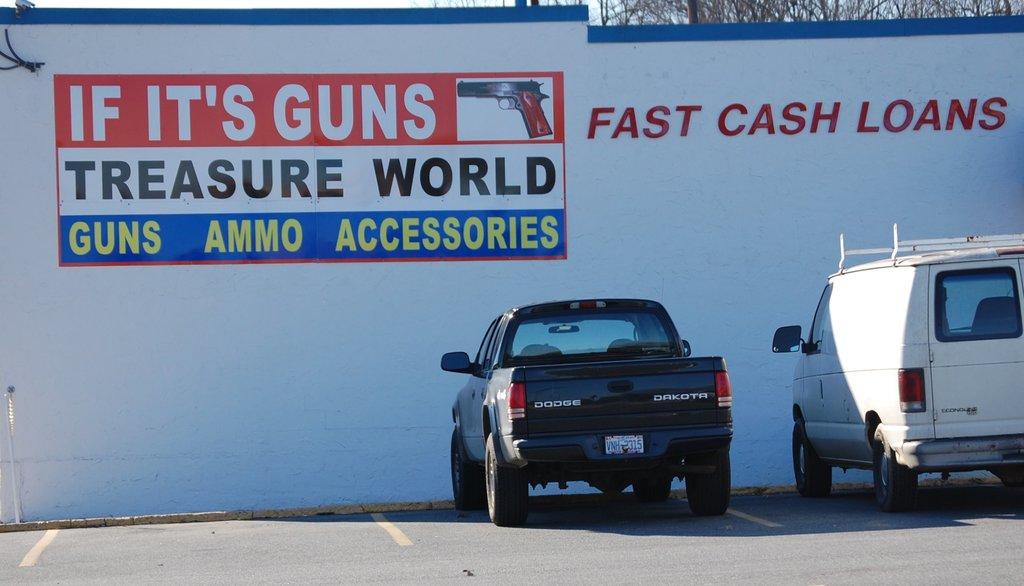What does this store sell?
Provide a succinct answer. Guns. Does the store give loans?
Your answer should be very brief. Yes. 